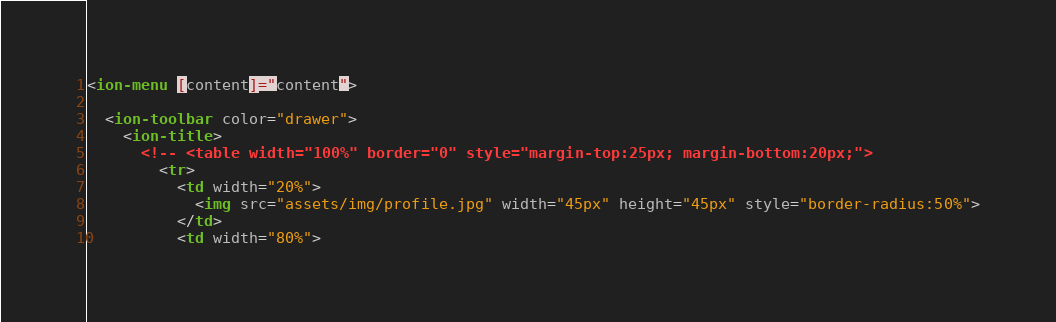<code> <loc_0><loc_0><loc_500><loc_500><_HTML_><ion-menu [content]="content">
 
  <ion-toolbar color="drawer">
    <ion-title>
      <!-- <table width="100%" border="0" style="margin-top:25px; margin-bottom:20px;">
        <tr>
          <td width="20%">
            <img src="assets/img/profile.jpg" width="45px" height="45px" style="border-radius:50%">
          </td>
          <td width="80%"></code> 